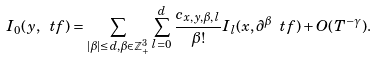Convert formula to latex. <formula><loc_0><loc_0><loc_500><loc_500>I _ { 0 } ( y , \ t f ) = \sum _ { | \beta | \leq d , \beta \in \mathbb { Z } _ { + } ^ { 3 } } \sum _ { l = 0 } ^ { d } \frac { c _ { x , y , \beta , l } } { \beta ! } I _ { l } ( x , \partial ^ { \beta } \ t f ) + O ( T ^ { - \gamma } ) .</formula> 